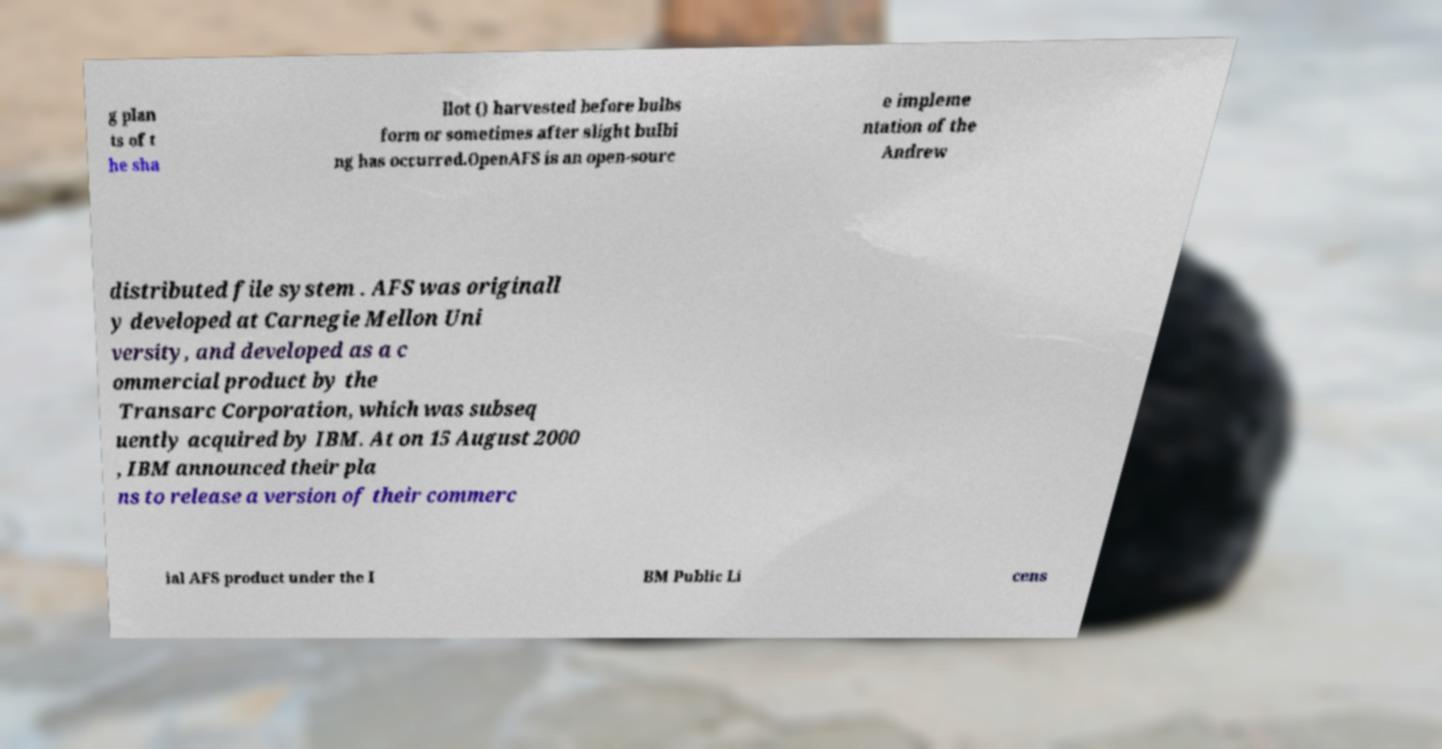Can you read and provide the text displayed in the image?This photo seems to have some interesting text. Can you extract and type it out for me? g plan ts of t he sha llot () harvested before bulbs form or sometimes after slight bulbi ng has occurred.OpenAFS is an open-sourc e impleme ntation of the Andrew distributed file system . AFS was originall y developed at Carnegie Mellon Uni versity, and developed as a c ommercial product by the Transarc Corporation, which was subseq uently acquired by IBM. At on 15 August 2000 , IBM announced their pla ns to release a version of their commerc ial AFS product under the I BM Public Li cens 